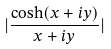Convert formula to latex. <formula><loc_0><loc_0><loc_500><loc_500>| \frac { \cosh ( x + i y ) } { x + i y } |</formula> 